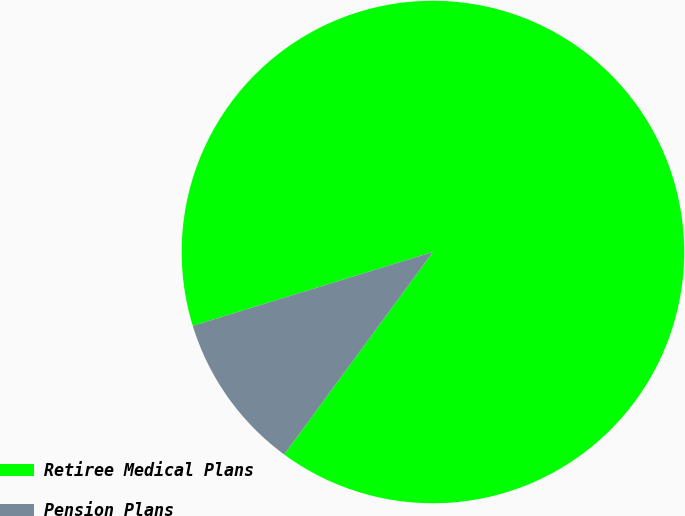Convert chart. <chart><loc_0><loc_0><loc_500><loc_500><pie_chart><fcel>Retiree Medical Plans<fcel>Pension Plans<nl><fcel>89.83%<fcel>10.17%<nl></chart> 